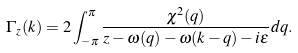<formula> <loc_0><loc_0><loc_500><loc_500>\Gamma _ { z } ( k ) = 2 \int _ { - \pi } ^ { \pi } \frac { \chi ^ { 2 } ( q ) } { z - \omega ( q ) - \omega ( k - q ) - i \varepsilon } d q .</formula> 